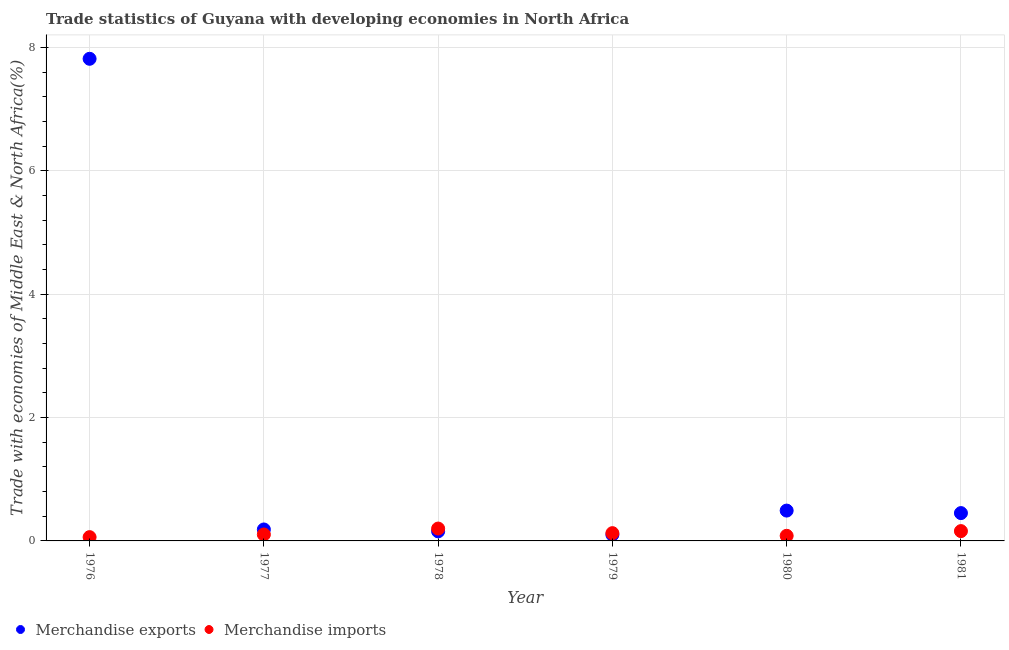What is the merchandise imports in 1978?
Offer a terse response. 0.2. Across all years, what is the maximum merchandise exports?
Provide a succinct answer. 7.82. Across all years, what is the minimum merchandise exports?
Your answer should be compact. 0.1. In which year was the merchandise imports maximum?
Make the answer very short. 1978. In which year was the merchandise exports minimum?
Your answer should be compact. 1979. What is the total merchandise exports in the graph?
Give a very brief answer. 9.2. What is the difference between the merchandise exports in 1978 and that in 1981?
Ensure brevity in your answer.  -0.3. What is the difference between the merchandise imports in 1976 and the merchandise exports in 1980?
Offer a very short reply. -0.43. What is the average merchandise imports per year?
Provide a short and direct response. 0.12. In the year 1980, what is the difference between the merchandise exports and merchandise imports?
Offer a terse response. 0.41. In how many years, is the merchandise imports greater than 0.4 %?
Offer a terse response. 0. What is the ratio of the merchandise imports in 1978 to that in 1979?
Ensure brevity in your answer.  1.59. Is the difference between the merchandise exports in 1976 and 1981 greater than the difference between the merchandise imports in 1976 and 1981?
Give a very brief answer. Yes. What is the difference between the highest and the second highest merchandise imports?
Provide a succinct answer. 0.04. What is the difference between the highest and the lowest merchandise imports?
Offer a terse response. 0.14. Is the sum of the merchandise imports in 1978 and 1980 greater than the maximum merchandise exports across all years?
Give a very brief answer. No. Is the merchandise exports strictly less than the merchandise imports over the years?
Make the answer very short. No. How many dotlines are there?
Ensure brevity in your answer.  2. What is the difference between two consecutive major ticks on the Y-axis?
Provide a succinct answer. 2. Are the values on the major ticks of Y-axis written in scientific E-notation?
Make the answer very short. No. How many legend labels are there?
Keep it short and to the point. 2. How are the legend labels stacked?
Make the answer very short. Horizontal. What is the title of the graph?
Your answer should be compact. Trade statistics of Guyana with developing economies in North Africa. What is the label or title of the Y-axis?
Provide a succinct answer. Trade with economies of Middle East & North Africa(%). What is the Trade with economies of Middle East & North Africa(%) in Merchandise exports in 1976?
Provide a short and direct response. 7.82. What is the Trade with economies of Middle East & North Africa(%) of Merchandise imports in 1976?
Provide a short and direct response. 0.06. What is the Trade with economies of Middle East & North Africa(%) in Merchandise exports in 1977?
Make the answer very short. 0.19. What is the Trade with economies of Middle East & North Africa(%) in Merchandise imports in 1977?
Offer a terse response. 0.1. What is the Trade with economies of Middle East & North Africa(%) of Merchandise exports in 1978?
Make the answer very short. 0.16. What is the Trade with economies of Middle East & North Africa(%) in Merchandise imports in 1978?
Offer a terse response. 0.2. What is the Trade with economies of Middle East & North Africa(%) in Merchandise exports in 1979?
Your answer should be compact. 0.1. What is the Trade with economies of Middle East & North Africa(%) in Merchandise imports in 1979?
Keep it short and to the point. 0.13. What is the Trade with economies of Middle East & North Africa(%) of Merchandise exports in 1980?
Give a very brief answer. 0.49. What is the Trade with economies of Middle East & North Africa(%) in Merchandise imports in 1980?
Give a very brief answer. 0.08. What is the Trade with economies of Middle East & North Africa(%) in Merchandise exports in 1981?
Keep it short and to the point. 0.45. What is the Trade with economies of Middle East & North Africa(%) in Merchandise imports in 1981?
Make the answer very short. 0.16. Across all years, what is the maximum Trade with economies of Middle East & North Africa(%) of Merchandise exports?
Your answer should be compact. 7.82. Across all years, what is the maximum Trade with economies of Middle East & North Africa(%) in Merchandise imports?
Offer a terse response. 0.2. Across all years, what is the minimum Trade with economies of Middle East & North Africa(%) of Merchandise exports?
Keep it short and to the point. 0.1. Across all years, what is the minimum Trade with economies of Middle East & North Africa(%) in Merchandise imports?
Offer a terse response. 0.06. What is the total Trade with economies of Middle East & North Africa(%) in Merchandise exports in the graph?
Ensure brevity in your answer.  9.2. What is the total Trade with economies of Middle East & North Africa(%) of Merchandise imports in the graph?
Offer a terse response. 0.73. What is the difference between the Trade with economies of Middle East & North Africa(%) in Merchandise exports in 1976 and that in 1977?
Ensure brevity in your answer.  7.63. What is the difference between the Trade with economies of Middle East & North Africa(%) of Merchandise imports in 1976 and that in 1977?
Make the answer very short. -0.04. What is the difference between the Trade with economies of Middle East & North Africa(%) of Merchandise exports in 1976 and that in 1978?
Provide a short and direct response. 7.66. What is the difference between the Trade with economies of Middle East & North Africa(%) in Merchandise imports in 1976 and that in 1978?
Make the answer very short. -0.14. What is the difference between the Trade with economies of Middle East & North Africa(%) in Merchandise exports in 1976 and that in 1979?
Your response must be concise. 7.72. What is the difference between the Trade with economies of Middle East & North Africa(%) in Merchandise imports in 1976 and that in 1979?
Make the answer very short. -0.06. What is the difference between the Trade with economies of Middle East & North Africa(%) in Merchandise exports in 1976 and that in 1980?
Give a very brief answer. 7.33. What is the difference between the Trade with economies of Middle East & North Africa(%) in Merchandise imports in 1976 and that in 1980?
Offer a terse response. -0.02. What is the difference between the Trade with economies of Middle East & North Africa(%) of Merchandise exports in 1976 and that in 1981?
Offer a terse response. 7.37. What is the difference between the Trade with economies of Middle East & North Africa(%) of Merchandise imports in 1976 and that in 1981?
Offer a very short reply. -0.1. What is the difference between the Trade with economies of Middle East & North Africa(%) in Merchandise exports in 1977 and that in 1978?
Make the answer very short. 0.03. What is the difference between the Trade with economies of Middle East & North Africa(%) in Merchandise imports in 1977 and that in 1978?
Ensure brevity in your answer.  -0.1. What is the difference between the Trade with economies of Middle East & North Africa(%) of Merchandise exports in 1977 and that in 1979?
Your answer should be very brief. 0.09. What is the difference between the Trade with economies of Middle East & North Africa(%) of Merchandise imports in 1977 and that in 1979?
Your response must be concise. -0.02. What is the difference between the Trade with economies of Middle East & North Africa(%) in Merchandise exports in 1977 and that in 1980?
Ensure brevity in your answer.  -0.31. What is the difference between the Trade with economies of Middle East & North Africa(%) of Merchandise imports in 1977 and that in 1980?
Ensure brevity in your answer.  0.02. What is the difference between the Trade with economies of Middle East & North Africa(%) of Merchandise exports in 1977 and that in 1981?
Keep it short and to the point. -0.27. What is the difference between the Trade with economies of Middle East & North Africa(%) of Merchandise imports in 1977 and that in 1981?
Make the answer very short. -0.06. What is the difference between the Trade with economies of Middle East & North Africa(%) of Merchandise exports in 1978 and that in 1979?
Provide a short and direct response. 0.05. What is the difference between the Trade with economies of Middle East & North Africa(%) of Merchandise imports in 1978 and that in 1979?
Give a very brief answer. 0.07. What is the difference between the Trade with economies of Middle East & North Africa(%) of Merchandise exports in 1978 and that in 1980?
Provide a short and direct response. -0.34. What is the difference between the Trade with economies of Middle East & North Africa(%) of Merchandise imports in 1978 and that in 1980?
Provide a succinct answer. 0.12. What is the difference between the Trade with economies of Middle East & North Africa(%) of Merchandise exports in 1978 and that in 1981?
Provide a short and direct response. -0.3. What is the difference between the Trade with economies of Middle East & North Africa(%) of Merchandise imports in 1978 and that in 1981?
Your answer should be very brief. 0.04. What is the difference between the Trade with economies of Middle East & North Africa(%) in Merchandise exports in 1979 and that in 1980?
Keep it short and to the point. -0.39. What is the difference between the Trade with economies of Middle East & North Africa(%) in Merchandise imports in 1979 and that in 1980?
Keep it short and to the point. 0.04. What is the difference between the Trade with economies of Middle East & North Africa(%) of Merchandise exports in 1979 and that in 1981?
Give a very brief answer. -0.35. What is the difference between the Trade with economies of Middle East & North Africa(%) in Merchandise imports in 1979 and that in 1981?
Offer a terse response. -0.03. What is the difference between the Trade with economies of Middle East & North Africa(%) of Merchandise exports in 1980 and that in 1981?
Make the answer very short. 0.04. What is the difference between the Trade with economies of Middle East & North Africa(%) in Merchandise imports in 1980 and that in 1981?
Your answer should be very brief. -0.08. What is the difference between the Trade with economies of Middle East & North Africa(%) in Merchandise exports in 1976 and the Trade with economies of Middle East & North Africa(%) in Merchandise imports in 1977?
Offer a terse response. 7.71. What is the difference between the Trade with economies of Middle East & North Africa(%) in Merchandise exports in 1976 and the Trade with economies of Middle East & North Africa(%) in Merchandise imports in 1978?
Offer a very short reply. 7.62. What is the difference between the Trade with economies of Middle East & North Africa(%) of Merchandise exports in 1976 and the Trade with economies of Middle East & North Africa(%) of Merchandise imports in 1979?
Provide a short and direct response. 7.69. What is the difference between the Trade with economies of Middle East & North Africa(%) of Merchandise exports in 1976 and the Trade with economies of Middle East & North Africa(%) of Merchandise imports in 1980?
Give a very brief answer. 7.74. What is the difference between the Trade with economies of Middle East & North Africa(%) of Merchandise exports in 1976 and the Trade with economies of Middle East & North Africa(%) of Merchandise imports in 1981?
Your answer should be very brief. 7.66. What is the difference between the Trade with economies of Middle East & North Africa(%) in Merchandise exports in 1977 and the Trade with economies of Middle East & North Africa(%) in Merchandise imports in 1978?
Offer a terse response. -0.01. What is the difference between the Trade with economies of Middle East & North Africa(%) in Merchandise exports in 1977 and the Trade with economies of Middle East & North Africa(%) in Merchandise imports in 1979?
Provide a succinct answer. 0.06. What is the difference between the Trade with economies of Middle East & North Africa(%) in Merchandise exports in 1977 and the Trade with economies of Middle East & North Africa(%) in Merchandise imports in 1980?
Ensure brevity in your answer.  0.1. What is the difference between the Trade with economies of Middle East & North Africa(%) in Merchandise exports in 1977 and the Trade with economies of Middle East & North Africa(%) in Merchandise imports in 1981?
Keep it short and to the point. 0.03. What is the difference between the Trade with economies of Middle East & North Africa(%) in Merchandise exports in 1978 and the Trade with economies of Middle East & North Africa(%) in Merchandise imports in 1979?
Make the answer very short. 0.03. What is the difference between the Trade with economies of Middle East & North Africa(%) in Merchandise exports in 1978 and the Trade with economies of Middle East & North Africa(%) in Merchandise imports in 1980?
Provide a succinct answer. 0.07. What is the difference between the Trade with economies of Middle East & North Africa(%) in Merchandise exports in 1978 and the Trade with economies of Middle East & North Africa(%) in Merchandise imports in 1981?
Ensure brevity in your answer.  -0. What is the difference between the Trade with economies of Middle East & North Africa(%) of Merchandise exports in 1979 and the Trade with economies of Middle East & North Africa(%) of Merchandise imports in 1980?
Your answer should be compact. 0.02. What is the difference between the Trade with economies of Middle East & North Africa(%) in Merchandise exports in 1979 and the Trade with economies of Middle East & North Africa(%) in Merchandise imports in 1981?
Your answer should be very brief. -0.06. What is the difference between the Trade with economies of Middle East & North Africa(%) in Merchandise exports in 1980 and the Trade with economies of Middle East & North Africa(%) in Merchandise imports in 1981?
Your response must be concise. 0.33. What is the average Trade with economies of Middle East & North Africa(%) of Merchandise exports per year?
Keep it short and to the point. 1.53. What is the average Trade with economies of Middle East & North Africa(%) in Merchandise imports per year?
Offer a very short reply. 0.12. In the year 1976, what is the difference between the Trade with economies of Middle East & North Africa(%) of Merchandise exports and Trade with economies of Middle East & North Africa(%) of Merchandise imports?
Provide a short and direct response. 7.76. In the year 1977, what is the difference between the Trade with economies of Middle East & North Africa(%) of Merchandise exports and Trade with economies of Middle East & North Africa(%) of Merchandise imports?
Offer a very short reply. 0.08. In the year 1978, what is the difference between the Trade with economies of Middle East & North Africa(%) of Merchandise exports and Trade with economies of Middle East & North Africa(%) of Merchandise imports?
Your answer should be compact. -0.05. In the year 1979, what is the difference between the Trade with economies of Middle East & North Africa(%) of Merchandise exports and Trade with economies of Middle East & North Africa(%) of Merchandise imports?
Your answer should be compact. -0.03. In the year 1980, what is the difference between the Trade with economies of Middle East & North Africa(%) of Merchandise exports and Trade with economies of Middle East & North Africa(%) of Merchandise imports?
Offer a terse response. 0.41. In the year 1981, what is the difference between the Trade with economies of Middle East & North Africa(%) of Merchandise exports and Trade with economies of Middle East & North Africa(%) of Merchandise imports?
Keep it short and to the point. 0.29. What is the ratio of the Trade with economies of Middle East & North Africa(%) of Merchandise exports in 1976 to that in 1977?
Make the answer very short. 42.08. What is the ratio of the Trade with economies of Middle East & North Africa(%) in Merchandise imports in 1976 to that in 1977?
Your response must be concise. 0.59. What is the ratio of the Trade with economies of Middle East & North Africa(%) in Merchandise exports in 1976 to that in 1978?
Offer a very short reply. 50.4. What is the ratio of the Trade with economies of Middle East & North Africa(%) in Merchandise imports in 1976 to that in 1978?
Offer a terse response. 0.31. What is the ratio of the Trade with economies of Middle East & North Africa(%) of Merchandise exports in 1976 to that in 1979?
Provide a succinct answer. 77.99. What is the ratio of the Trade with economies of Middle East & North Africa(%) of Merchandise imports in 1976 to that in 1979?
Keep it short and to the point. 0.49. What is the ratio of the Trade with economies of Middle East & North Africa(%) in Merchandise exports in 1976 to that in 1980?
Keep it short and to the point. 15.89. What is the ratio of the Trade with economies of Middle East & North Africa(%) of Merchandise imports in 1976 to that in 1980?
Your answer should be very brief. 0.74. What is the ratio of the Trade with economies of Middle East & North Africa(%) of Merchandise exports in 1976 to that in 1981?
Your answer should be compact. 17.32. What is the ratio of the Trade with economies of Middle East & North Africa(%) in Merchandise imports in 1976 to that in 1981?
Ensure brevity in your answer.  0.39. What is the ratio of the Trade with economies of Middle East & North Africa(%) of Merchandise exports in 1977 to that in 1978?
Your answer should be very brief. 1.2. What is the ratio of the Trade with economies of Middle East & North Africa(%) in Merchandise imports in 1977 to that in 1978?
Make the answer very short. 0.52. What is the ratio of the Trade with economies of Middle East & North Africa(%) in Merchandise exports in 1977 to that in 1979?
Provide a succinct answer. 1.85. What is the ratio of the Trade with economies of Middle East & North Africa(%) of Merchandise imports in 1977 to that in 1979?
Your answer should be very brief. 0.83. What is the ratio of the Trade with economies of Middle East & North Africa(%) in Merchandise exports in 1977 to that in 1980?
Your response must be concise. 0.38. What is the ratio of the Trade with economies of Middle East & North Africa(%) in Merchandise imports in 1977 to that in 1980?
Offer a very short reply. 1.26. What is the ratio of the Trade with economies of Middle East & North Africa(%) in Merchandise exports in 1977 to that in 1981?
Your answer should be compact. 0.41. What is the ratio of the Trade with economies of Middle East & North Africa(%) in Merchandise imports in 1977 to that in 1981?
Your answer should be very brief. 0.65. What is the ratio of the Trade with economies of Middle East & North Africa(%) in Merchandise exports in 1978 to that in 1979?
Offer a very short reply. 1.55. What is the ratio of the Trade with economies of Middle East & North Africa(%) of Merchandise imports in 1978 to that in 1979?
Provide a succinct answer. 1.59. What is the ratio of the Trade with economies of Middle East & North Africa(%) of Merchandise exports in 1978 to that in 1980?
Make the answer very short. 0.32. What is the ratio of the Trade with economies of Middle East & North Africa(%) of Merchandise imports in 1978 to that in 1980?
Give a very brief answer. 2.42. What is the ratio of the Trade with economies of Middle East & North Africa(%) in Merchandise exports in 1978 to that in 1981?
Offer a terse response. 0.34. What is the ratio of the Trade with economies of Middle East & North Africa(%) of Merchandise imports in 1978 to that in 1981?
Your response must be concise. 1.26. What is the ratio of the Trade with economies of Middle East & North Africa(%) in Merchandise exports in 1979 to that in 1980?
Your response must be concise. 0.2. What is the ratio of the Trade with economies of Middle East & North Africa(%) in Merchandise imports in 1979 to that in 1980?
Offer a very short reply. 1.52. What is the ratio of the Trade with economies of Middle East & North Africa(%) in Merchandise exports in 1979 to that in 1981?
Ensure brevity in your answer.  0.22. What is the ratio of the Trade with economies of Middle East & North Africa(%) of Merchandise imports in 1979 to that in 1981?
Your response must be concise. 0.79. What is the ratio of the Trade with economies of Middle East & North Africa(%) of Merchandise exports in 1980 to that in 1981?
Offer a very short reply. 1.09. What is the ratio of the Trade with economies of Middle East & North Africa(%) in Merchandise imports in 1980 to that in 1981?
Your answer should be very brief. 0.52. What is the difference between the highest and the second highest Trade with economies of Middle East & North Africa(%) of Merchandise exports?
Your answer should be very brief. 7.33. What is the difference between the highest and the second highest Trade with economies of Middle East & North Africa(%) of Merchandise imports?
Your answer should be very brief. 0.04. What is the difference between the highest and the lowest Trade with economies of Middle East & North Africa(%) in Merchandise exports?
Your answer should be very brief. 7.72. What is the difference between the highest and the lowest Trade with economies of Middle East & North Africa(%) of Merchandise imports?
Offer a terse response. 0.14. 